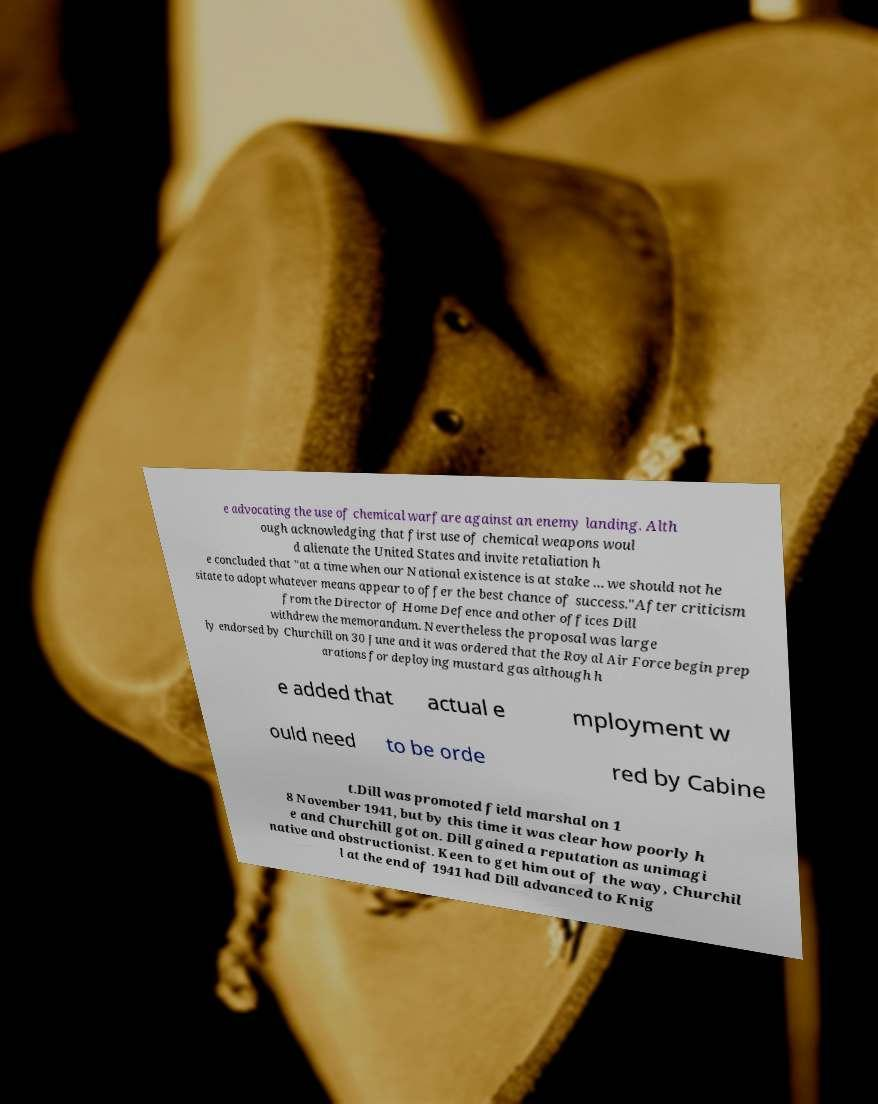Please read and relay the text visible in this image. What does it say? e advocating the use of chemical warfare against an enemy landing. Alth ough acknowledging that first use of chemical weapons woul d alienate the United States and invite retaliation h e concluded that "at a time when our National existence is at stake ... we should not he sitate to adopt whatever means appear to offer the best chance of success."After criticism from the Director of Home Defence and other offices Dill withdrew the memorandum. Nevertheless the proposal was large ly endorsed by Churchill on 30 June and it was ordered that the Royal Air Force begin prep arations for deploying mustard gas although h e added that actual e mployment w ould need to be orde red by Cabine t.Dill was promoted field marshal on 1 8 November 1941, but by this time it was clear how poorly h e and Churchill got on. Dill gained a reputation as unimagi native and obstructionist. Keen to get him out of the way, Churchil l at the end of 1941 had Dill advanced to Knig 